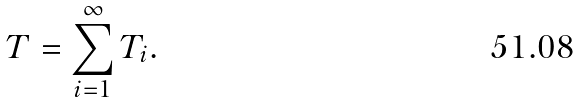<formula> <loc_0><loc_0><loc_500><loc_500>T = \sum _ { i = 1 } ^ { \infty } T _ { i } .</formula> 